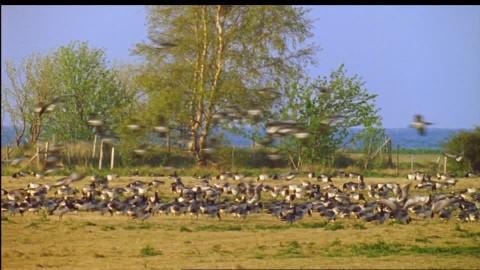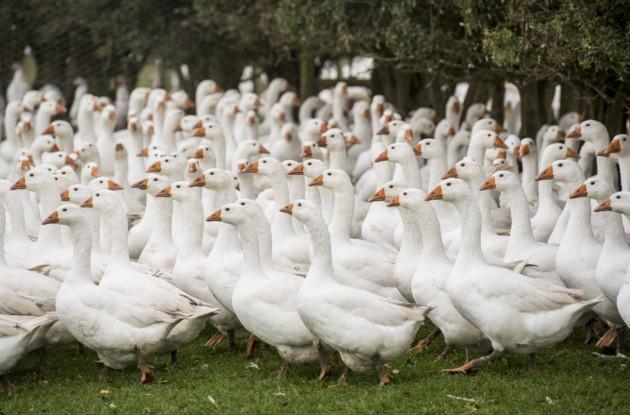The first image is the image on the left, the second image is the image on the right. Analyze the images presented: Is the assertion "An image shows a man holding out some type of stick while standing on a green field behind ducks." valid? Answer yes or no. No. The first image is the image on the left, the second image is the image on the right. For the images shown, is this caption "One of the images shows a person holding a stick." true? Answer yes or no. No. 